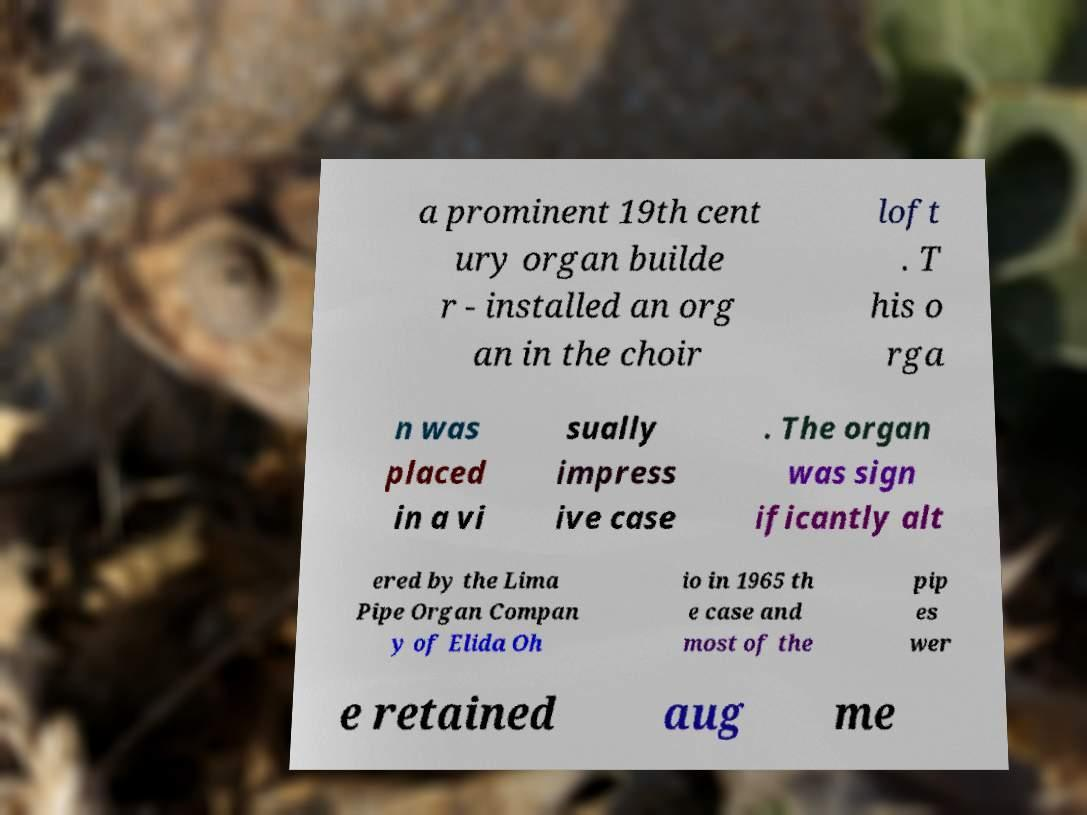Please identify and transcribe the text found in this image. a prominent 19th cent ury organ builde r - installed an org an in the choir loft . T his o rga n was placed in a vi sually impress ive case . The organ was sign ificantly alt ered by the Lima Pipe Organ Compan y of Elida Oh io in 1965 th e case and most of the pip es wer e retained aug me 